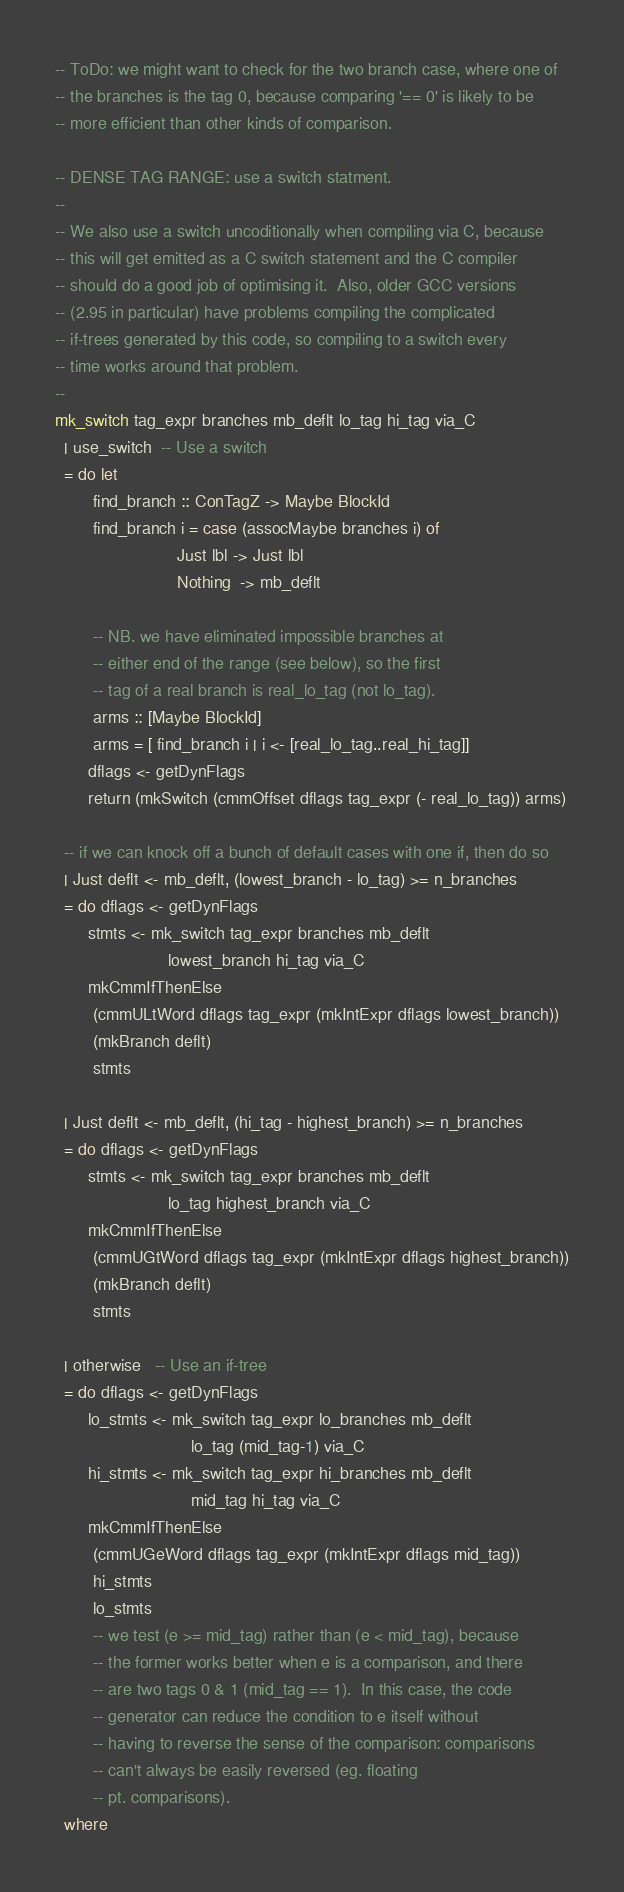<code> <loc_0><loc_0><loc_500><loc_500><_Haskell_>-- ToDo: we might want to check for the two branch case, where one of
-- the branches is the tag 0, because comparing '== 0' is likely to be
-- more efficient than other kinds of comparison.

-- DENSE TAG RANGE: use a switch statment.
--
-- We also use a switch uncoditionally when compiling via C, because
-- this will get emitted as a C switch statement and the C compiler
-- should do a good job of optimising it.  Also, older GCC versions
-- (2.95 in particular) have problems compiling the complicated
-- if-trees generated by this code, so compiling to a switch every
-- time works around that problem.
--
mk_switch tag_expr branches mb_deflt lo_tag hi_tag via_C
  | use_switch  -- Use a switch
  = do let
        find_branch :: ConTagZ -> Maybe BlockId
        find_branch i = case (assocMaybe branches i) of
                          Just lbl -> Just lbl
                          Nothing  -> mb_deflt

        -- NB. we have eliminated impossible branches at
        -- either end of the range (see below), so the first
        -- tag of a real branch is real_lo_tag (not lo_tag).
        arms :: [Maybe BlockId]
        arms = [ find_branch i | i <- [real_lo_tag..real_hi_tag]]
       dflags <- getDynFlags
       return (mkSwitch (cmmOffset dflags tag_expr (- real_lo_tag)) arms)

  -- if we can knock off a bunch of default cases with one if, then do so
  | Just deflt <- mb_deflt, (lowest_branch - lo_tag) >= n_branches
  = do dflags <- getDynFlags
       stmts <- mk_switch tag_expr branches mb_deflt
                        lowest_branch hi_tag via_C
       mkCmmIfThenElse
        (cmmULtWord dflags tag_expr (mkIntExpr dflags lowest_branch))
        (mkBranch deflt)
        stmts

  | Just deflt <- mb_deflt, (hi_tag - highest_branch) >= n_branches
  = do dflags <- getDynFlags
       stmts <- mk_switch tag_expr branches mb_deflt
                        lo_tag highest_branch via_C
       mkCmmIfThenElse
        (cmmUGtWord dflags tag_expr (mkIntExpr dflags highest_branch))
        (mkBranch deflt)
        stmts

  | otherwise   -- Use an if-tree
  = do dflags <- getDynFlags
       lo_stmts <- mk_switch tag_expr lo_branches mb_deflt
                             lo_tag (mid_tag-1) via_C
       hi_stmts <- mk_switch tag_expr hi_branches mb_deflt
                             mid_tag hi_tag via_C
       mkCmmIfThenElse
        (cmmUGeWord dflags tag_expr (mkIntExpr dflags mid_tag))
        hi_stmts
        lo_stmts
        -- we test (e >= mid_tag) rather than (e < mid_tag), because
        -- the former works better when e is a comparison, and there
        -- are two tags 0 & 1 (mid_tag == 1).  In this case, the code
        -- generator can reduce the condition to e itself without
        -- having to reverse the sense of the comparison: comparisons
        -- can't always be easily reversed (eg. floating
        -- pt. comparisons).
  where</code> 